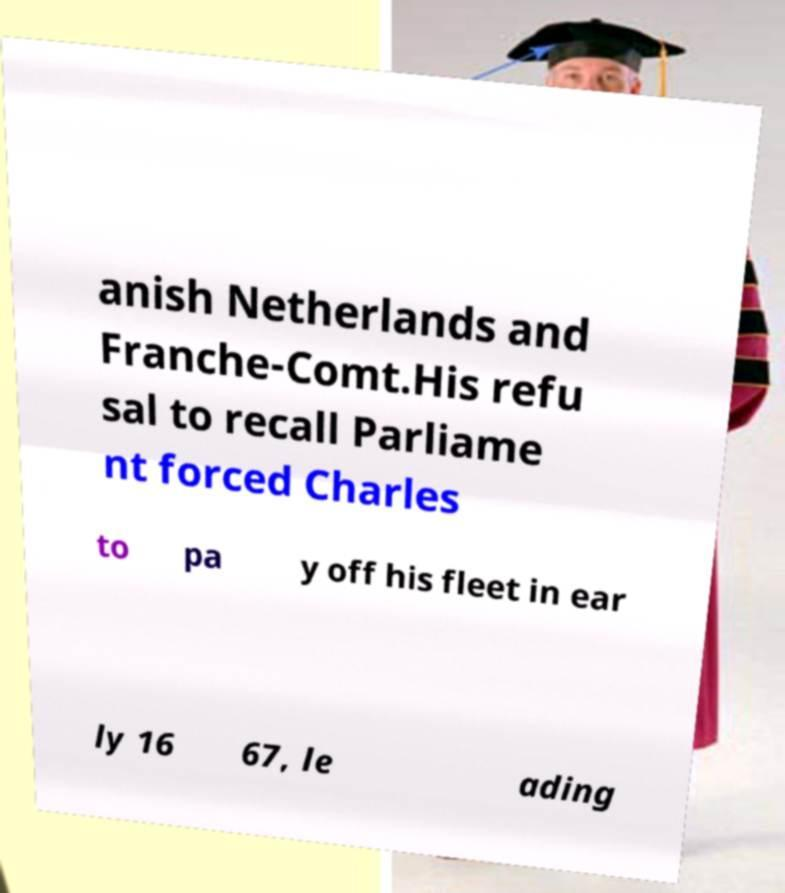I need the written content from this picture converted into text. Can you do that? anish Netherlands and Franche-Comt.His refu sal to recall Parliame nt forced Charles to pa y off his fleet in ear ly 16 67, le ading 